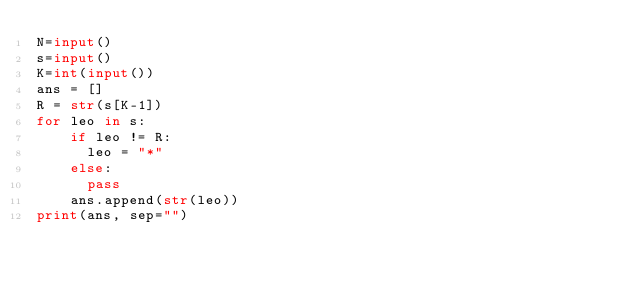<code> <loc_0><loc_0><loc_500><loc_500><_Python_>N=input()
s=input()
K=int(input())
ans = []
R = str(s[K-1])
for leo in s:
    if leo != R:
	   	leo = "*"
    else:
    	pass
    ans.append(str(leo))  
print(ans, sep="")

 
</code> 